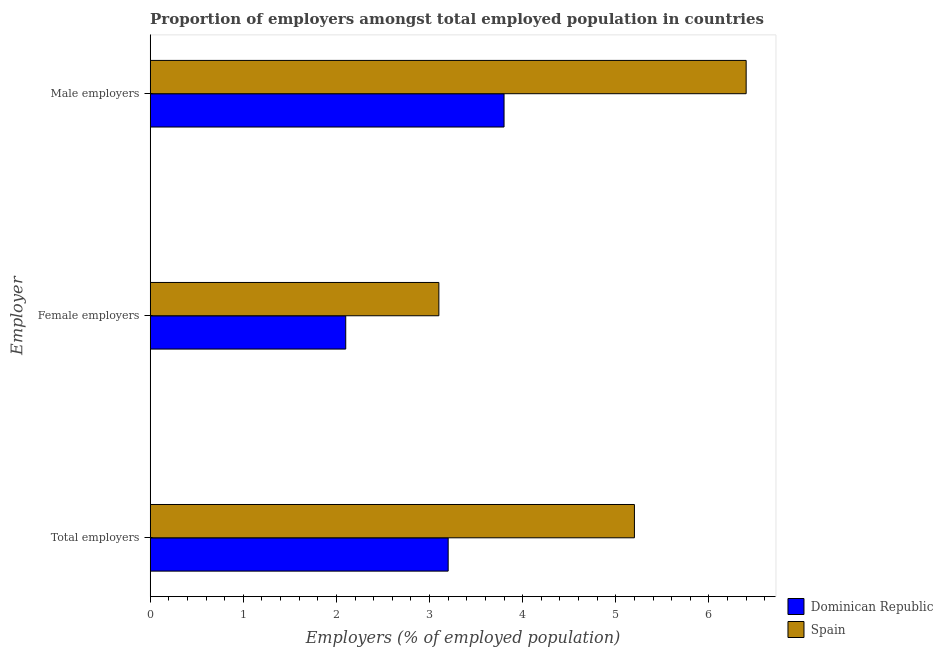Are the number of bars on each tick of the Y-axis equal?
Your answer should be very brief. Yes. How many bars are there on the 3rd tick from the top?
Ensure brevity in your answer.  2. How many bars are there on the 2nd tick from the bottom?
Offer a terse response. 2. What is the label of the 3rd group of bars from the top?
Make the answer very short. Total employers. What is the percentage of male employers in Dominican Republic?
Your response must be concise. 3.8. Across all countries, what is the maximum percentage of male employers?
Ensure brevity in your answer.  6.4. Across all countries, what is the minimum percentage of female employers?
Offer a very short reply. 2.1. In which country was the percentage of male employers maximum?
Offer a very short reply. Spain. In which country was the percentage of total employers minimum?
Make the answer very short. Dominican Republic. What is the total percentage of female employers in the graph?
Provide a succinct answer. 5.2. What is the difference between the percentage of total employers in Dominican Republic and that in Spain?
Your answer should be compact. -2. What is the difference between the percentage of total employers in Spain and the percentage of female employers in Dominican Republic?
Your answer should be compact. 3.1. What is the average percentage of total employers per country?
Keep it short and to the point. 4.2. What is the difference between the percentage of total employers and percentage of male employers in Spain?
Offer a terse response. -1.2. What is the ratio of the percentage of female employers in Spain to that in Dominican Republic?
Provide a short and direct response. 1.48. Is the difference between the percentage of total employers in Dominican Republic and Spain greater than the difference between the percentage of female employers in Dominican Republic and Spain?
Your answer should be very brief. No. What is the difference between the highest and the second highest percentage of male employers?
Give a very brief answer. 2.6. What does the 1st bar from the top in Male employers represents?
Ensure brevity in your answer.  Spain. What does the 1st bar from the bottom in Male employers represents?
Your response must be concise. Dominican Republic. How many countries are there in the graph?
Provide a short and direct response. 2. What is the difference between two consecutive major ticks on the X-axis?
Keep it short and to the point. 1. Are the values on the major ticks of X-axis written in scientific E-notation?
Offer a terse response. No. Does the graph contain grids?
Offer a terse response. No. Where does the legend appear in the graph?
Give a very brief answer. Bottom right. How are the legend labels stacked?
Ensure brevity in your answer.  Vertical. What is the title of the graph?
Offer a terse response. Proportion of employers amongst total employed population in countries. Does "Palau" appear as one of the legend labels in the graph?
Offer a very short reply. No. What is the label or title of the X-axis?
Provide a short and direct response. Employers (% of employed population). What is the label or title of the Y-axis?
Offer a terse response. Employer. What is the Employers (% of employed population) in Dominican Republic in Total employers?
Offer a very short reply. 3.2. What is the Employers (% of employed population) of Spain in Total employers?
Provide a succinct answer. 5.2. What is the Employers (% of employed population) of Dominican Republic in Female employers?
Keep it short and to the point. 2.1. What is the Employers (% of employed population) in Spain in Female employers?
Your response must be concise. 3.1. What is the Employers (% of employed population) of Dominican Republic in Male employers?
Your response must be concise. 3.8. What is the Employers (% of employed population) in Spain in Male employers?
Keep it short and to the point. 6.4. Across all Employer, what is the maximum Employers (% of employed population) of Dominican Republic?
Provide a short and direct response. 3.8. Across all Employer, what is the maximum Employers (% of employed population) of Spain?
Keep it short and to the point. 6.4. Across all Employer, what is the minimum Employers (% of employed population) of Dominican Republic?
Provide a succinct answer. 2.1. Across all Employer, what is the minimum Employers (% of employed population) in Spain?
Provide a succinct answer. 3.1. What is the total Employers (% of employed population) of Dominican Republic in the graph?
Provide a short and direct response. 9.1. What is the difference between the Employers (% of employed population) of Dominican Republic in Total employers and that in Female employers?
Keep it short and to the point. 1.1. What is the difference between the Employers (% of employed population) of Spain in Total employers and that in Female employers?
Give a very brief answer. 2.1. What is the difference between the Employers (% of employed population) in Spain in Total employers and that in Male employers?
Your answer should be compact. -1.2. What is the difference between the Employers (% of employed population) of Dominican Republic in Female employers and that in Male employers?
Offer a terse response. -1.7. What is the difference between the Employers (% of employed population) in Dominican Republic in Total employers and the Employers (% of employed population) in Spain in Male employers?
Ensure brevity in your answer.  -3.2. What is the difference between the Employers (% of employed population) in Dominican Republic in Female employers and the Employers (% of employed population) in Spain in Male employers?
Your response must be concise. -4.3. What is the average Employers (% of employed population) of Dominican Republic per Employer?
Offer a very short reply. 3.03. What is the difference between the Employers (% of employed population) in Dominican Republic and Employers (% of employed population) in Spain in Female employers?
Offer a very short reply. -1. What is the difference between the Employers (% of employed population) of Dominican Republic and Employers (% of employed population) of Spain in Male employers?
Offer a terse response. -2.6. What is the ratio of the Employers (% of employed population) of Dominican Republic in Total employers to that in Female employers?
Ensure brevity in your answer.  1.52. What is the ratio of the Employers (% of employed population) in Spain in Total employers to that in Female employers?
Offer a very short reply. 1.68. What is the ratio of the Employers (% of employed population) in Dominican Republic in Total employers to that in Male employers?
Make the answer very short. 0.84. What is the ratio of the Employers (% of employed population) in Spain in Total employers to that in Male employers?
Your answer should be compact. 0.81. What is the ratio of the Employers (% of employed population) in Dominican Republic in Female employers to that in Male employers?
Ensure brevity in your answer.  0.55. What is the ratio of the Employers (% of employed population) of Spain in Female employers to that in Male employers?
Offer a very short reply. 0.48. What is the difference between the highest and the second highest Employers (% of employed population) in Dominican Republic?
Give a very brief answer. 0.6. What is the difference between the highest and the lowest Employers (% of employed population) of Dominican Republic?
Your answer should be compact. 1.7. 